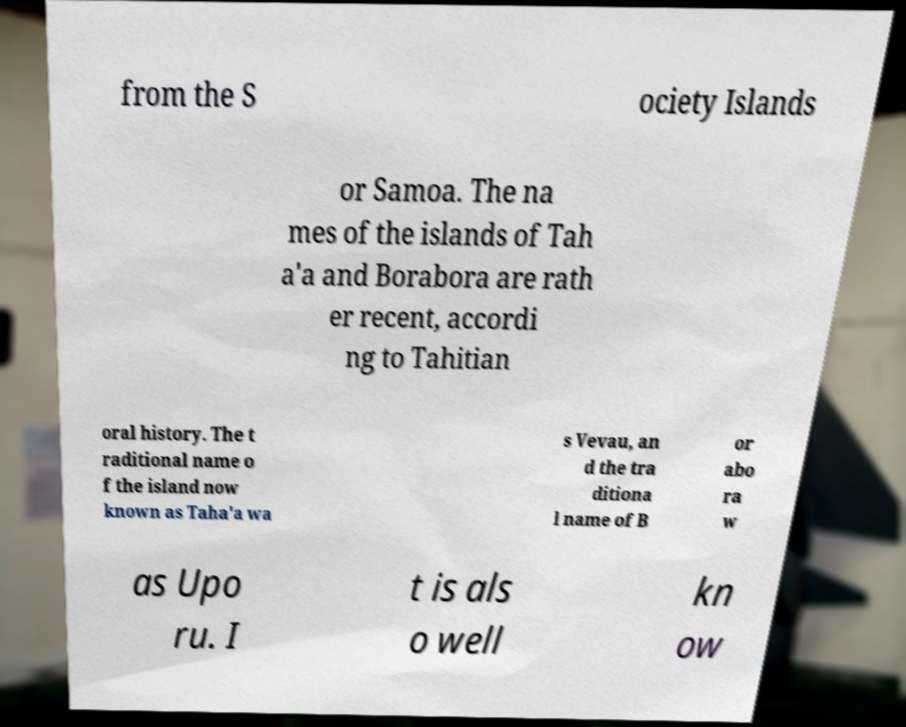For documentation purposes, I need the text within this image transcribed. Could you provide that? from the S ociety Islands or Samoa. The na mes of the islands of Tah a'a and Borabora are rath er recent, accordi ng to Tahitian oral history. The t raditional name o f the island now known as Taha'a wa s Vevau, an d the tra ditiona l name of B or abo ra w as Upo ru. I t is als o well kn ow 